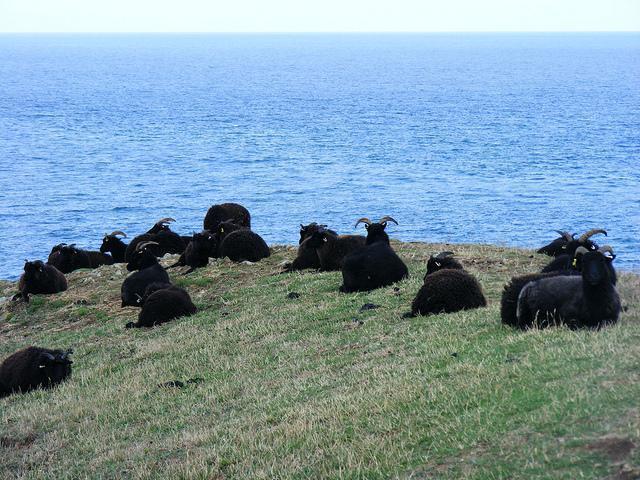How many sheep are there?
Give a very brief answer. 6. 